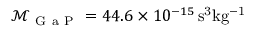Convert formula to latex. <formula><loc_0><loc_0><loc_500><loc_500>\mathcal { M } _ { G a P } = 4 4 . 6 \times 1 0 ^ { - 1 5 } \, s ^ { 3 } k g ^ { - 1 }</formula> 